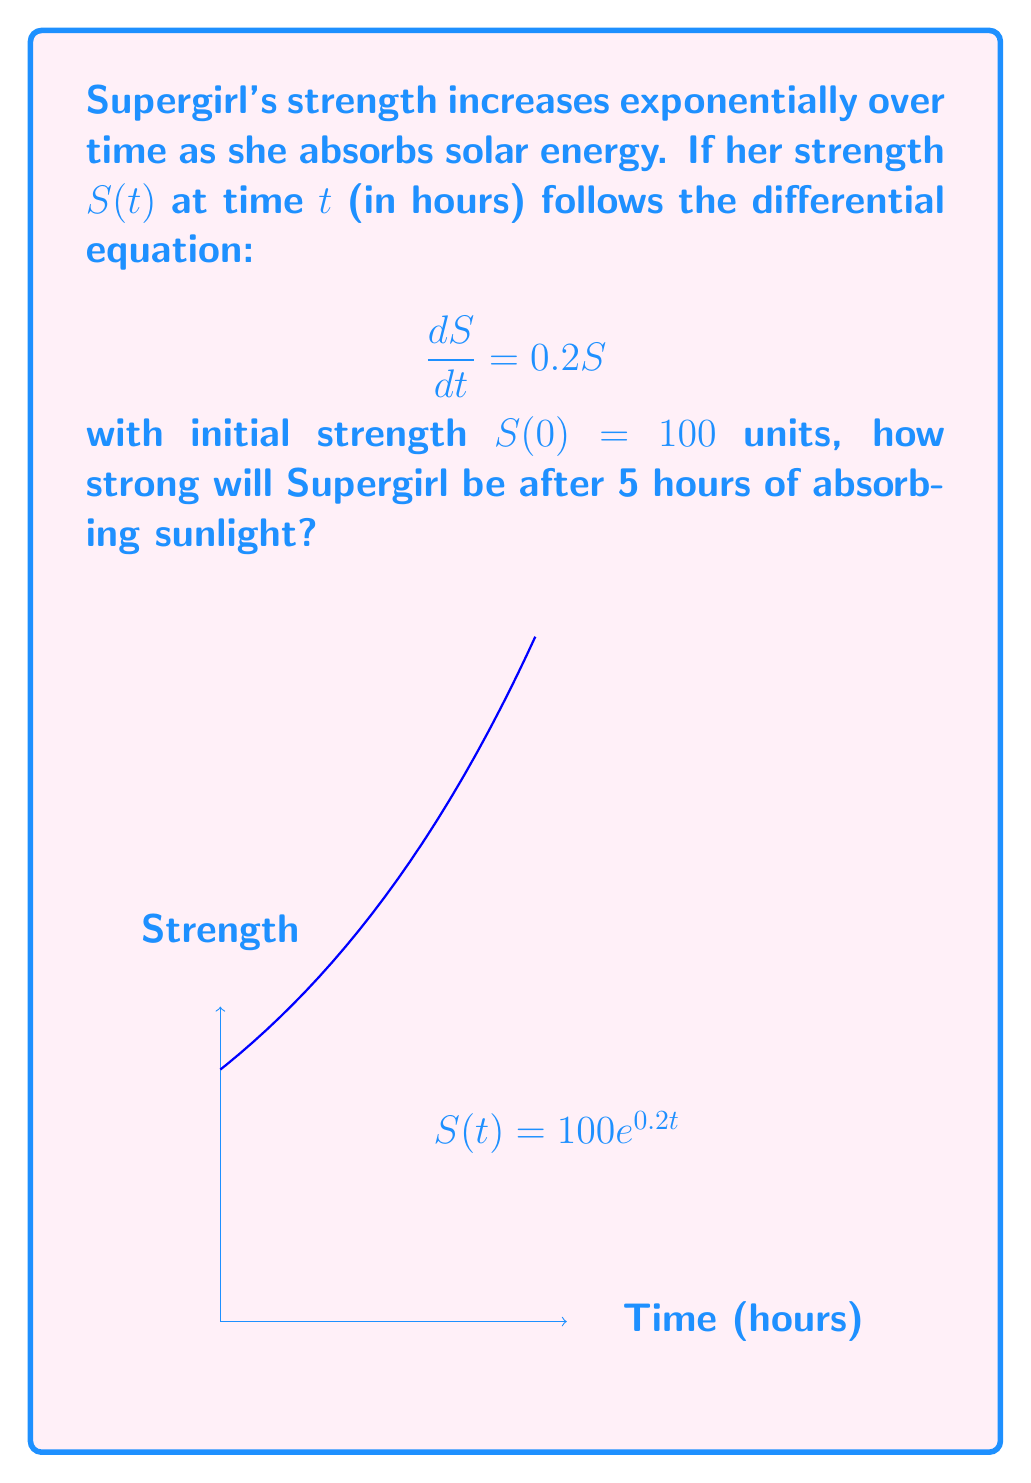Solve this math problem. Let's solve this step-by-step:

1) We have the differential equation $\frac{dS}{dt} = 0.2S$ with initial condition $S(0) = 100$.

2) This is a separable differential equation. We can solve it as follows:

   $$\frac{dS}{S} = 0.2dt$$

3) Integrating both sides:

   $$\int \frac{dS}{S} = \int 0.2dt$$
   $$\ln|S| = 0.2t + C$$

4) Solving for S:

   $$S = e^{0.2t + C} = e^C \cdot e^{0.2t}$$

5) Let $A = e^C$. Then our general solution is:

   $$S(t) = Ae^{0.2t}$$

6) Using the initial condition $S(0) = 100$:

   $$100 = Ae^{0 \cdot 0.2} = A$$

7) Therefore, our particular solution is:

   $$S(t) = 100e^{0.2t}$$

8) To find Supergirl's strength after 5 hours, we calculate $S(5)$:

   $$S(5) = 100e^{0.2 \cdot 5} = 100e^1 \approx 271.83$$
Answer: 271.83 units 